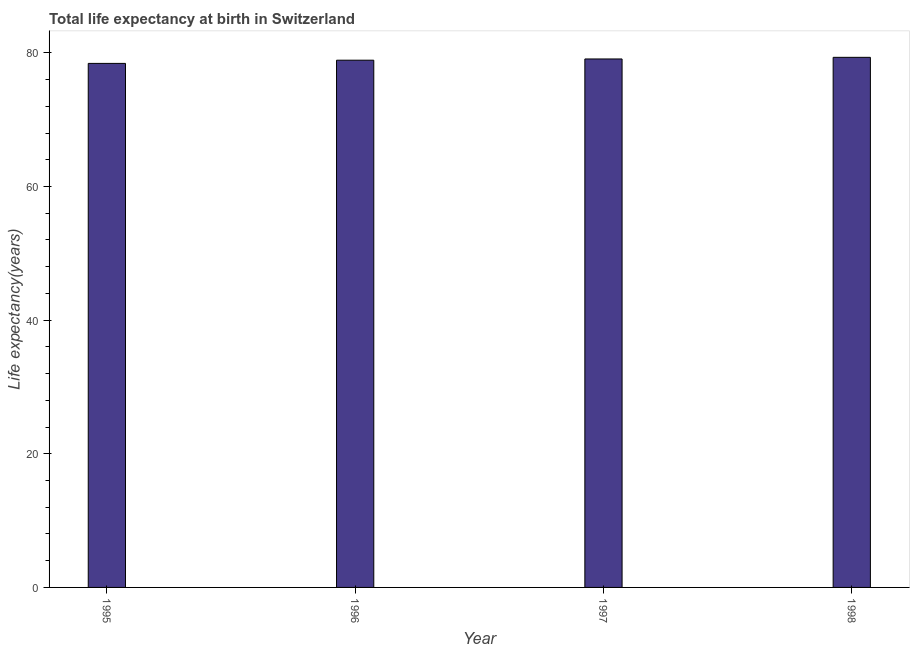What is the title of the graph?
Your answer should be compact. Total life expectancy at birth in Switzerland. What is the label or title of the Y-axis?
Keep it short and to the point. Life expectancy(years). What is the life expectancy at birth in 1998?
Give a very brief answer. 79.32. Across all years, what is the maximum life expectancy at birth?
Offer a terse response. 79.32. Across all years, what is the minimum life expectancy at birth?
Make the answer very short. 78.42. What is the sum of the life expectancy at birth?
Provide a short and direct response. 315.72. What is the difference between the life expectancy at birth in 1995 and 1998?
Offer a terse response. -0.91. What is the average life expectancy at birth per year?
Provide a short and direct response. 78.93. What is the median life expectancy at birth?
Offer a very short reply. 78.99. In how many years, is the life expectancy at birth greater than 24 years?
Your response must be concise. 4. Do a majority of the years between 1998 and 1997 (inclusive) have life expectancy at birth greater than 48 years?
Make the answer very short. No. Is the life expectancy at birth in 1995 less than that in 1997?
Offer a very short reply. Yes. What is the difference between the highest and the second highest life expectancy at birth?
Your answer should be very brief. 0.24. Is the sum of the life expectancy at birth in 1995 and 1997 greater than the maximum life expectancy at birth across all years?
Keep it short and to the point. Yes. What is the difference between the highest and the lowest life expectancy at birth?
Provide a short and direct response. 0.91. Are all the bars in the graph horizontal?
Offer a terse response. No. How many years are there in the graph?
Keep it short and to the point. 4. What is the difference between two consecutive major ticks on the Y-axis?
Keep it short and to the point. 20. Are the values on the major ticks of Y-axis written in scientific E-notation?
Make the answer very short. No. What is the Life expectancy(years) of 1995?
Ensure brevity in your answer.  78.42. What is the Life expectancy(years) in 1996?
Your answer should be compact. 78.9. What is the Life expectancy(years) in 1997?
Your answer should be very brief. 79.08. What is the Life expectancy(years) in 1998?
Your response must be concise. 79.32. What is the difference between the Life expectancy(years) in 1995 and 1996?
Offer a terse response. -0.48. What is the difference between the Life expectancy(years) in 1995 and 1997?
Provide a succinct answer. -0.66. What is the difference between the Life expectancy(years) in 1995 and 1998?
Ensure brevity in your answer.  -0.91. What is the difference between the Life expectancy(years) in 1996 and 1997?
Keep it short and to the point. -0.18. What is the difference between the Life expectancy(years) in 1996 and 1998?
Ensure brevity in your answer.  -0.43. What is the difference between the Life expectancy(years) in 1997 and 1998?
Offer a very short reply. -0.24. What is the ratio of the Life expectancy(years) in 1995 to that in 1996?
Keep it short and to the point. 0.99. What is the ratio of the Life expectancy(years) in 1995 to that in 1998?
Make the answer very short. 0.99. What is the ratio of the Life expectancy(years) in 1996 to that in 1997?
Your answer should be compact. 1. What is the ratio of the Life expectancy(years) in 1997 to that in 1998?
Keep it short and to the point. 1. 